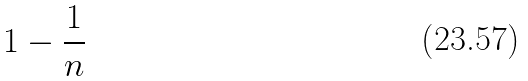<formula> <loc_0><loc_0><loc_500><loc_500>1 - { \frac { 1 } { n } }</formula> 